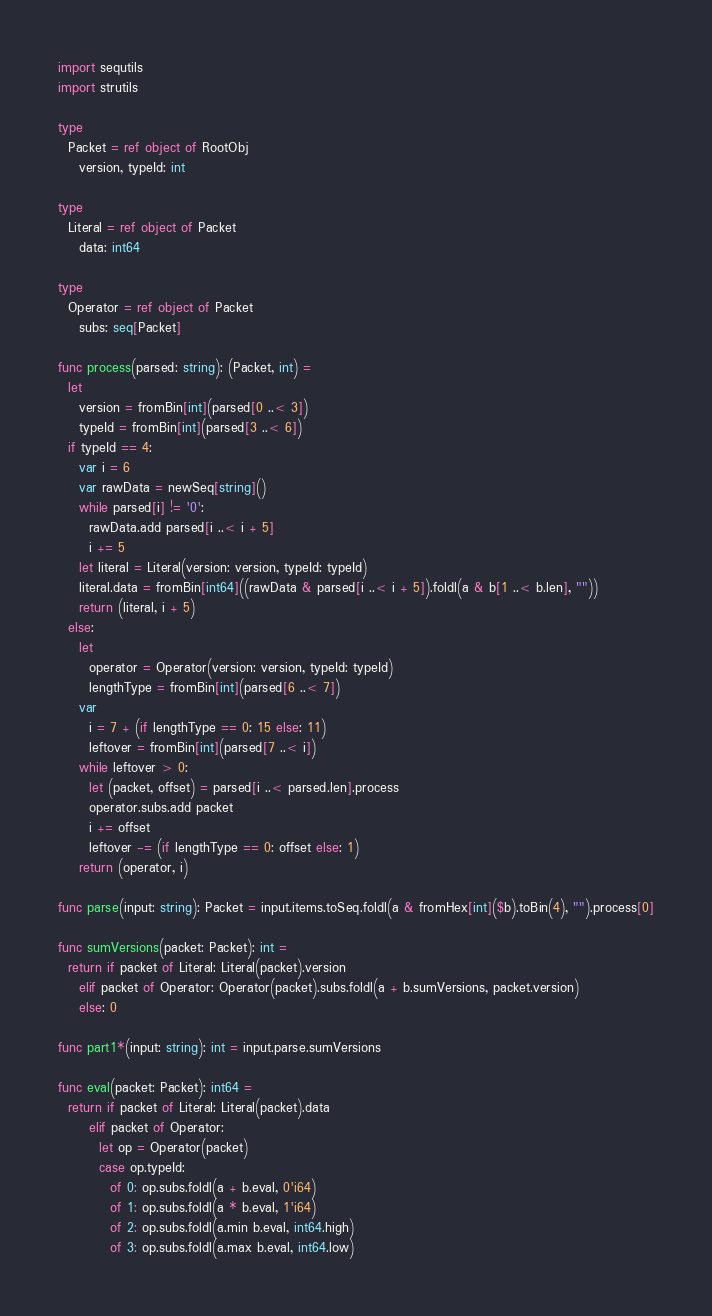Convert code to text. <code><loc_0><loc_0><loc_500><loc_500><_Nim_>import sequtils
import strutils

type
  Packet = ref object of RootObj
    version, typeId: int

type
  Literal = ref object of Packet
    data: int64

type
  Operator = ref object of Packet
    subs: seq[Packet]

func process(parsed: string): (Packet, int) =
  let
    version = fromBin[int](parsed[0 ..< 3])
    typeId = fromBin[int](parsed[3 ..< 6])
  if typeId == 4:
    var i = 6
    var rawData = newSeq[string]()
    while parsed[i] != '0':
      rawData.add parsed[i ..< i + 5]
      i += 5
    let literal = Literal(version: version, typeId: typeId)
    literal.data = fromBin[int64]((rawData & parsed[i ..< i + 5]).foldl(a & b[1 ..< b.len], ""))
    return (literal, i + 5)
  else:
    let
      operator = Operator(version: version, typeId: typeId)
      lengthType = fromBin[int](parsed[6 ..< 7])
    var
      i = 7 + (if lengthType == 0: 15 else: 11)
      leftover = fromBin[int](parsed[7 ..< i])
    while leftover > 0:
      let (packet, offset) = parsed[i ..< parsed.len].process
      operator.subs.add packet
      i += offset
      leftover -= (if lengthType == 0: offset else: 1)
    return (operator, i)

func parse(input: string): Packet = input.items.toSeq.foldl(a & fromHex[int]($b).toBin(4), "").process[0]

func sumVersions(packet: Packet): int =
  return if packet of Literal: Literal(packet).version
    elif packet of Operator: Operator(packet).subs.foldl(a + b.sumVersions, packet.version)
    else: 0

func part1*(input: string): int = input.parse.sumVersions

func eval(packet: Packet): int64 =
  return if packet of Literal: Literal(packet).data
      elif packet of Operator:
        let op = Operator(packet)
        case op.typeId:
          of 0: op.subs.foldl(a + b.eval, 0'i64)
          of 1: op.subs.foldl(a * b.eval, 1'i64)
          of 2: op.subs.foldl(a.min b.eval, int64.high)
          of 3: op.subs.foldl(a.max b.eval, int64.low)</code> 